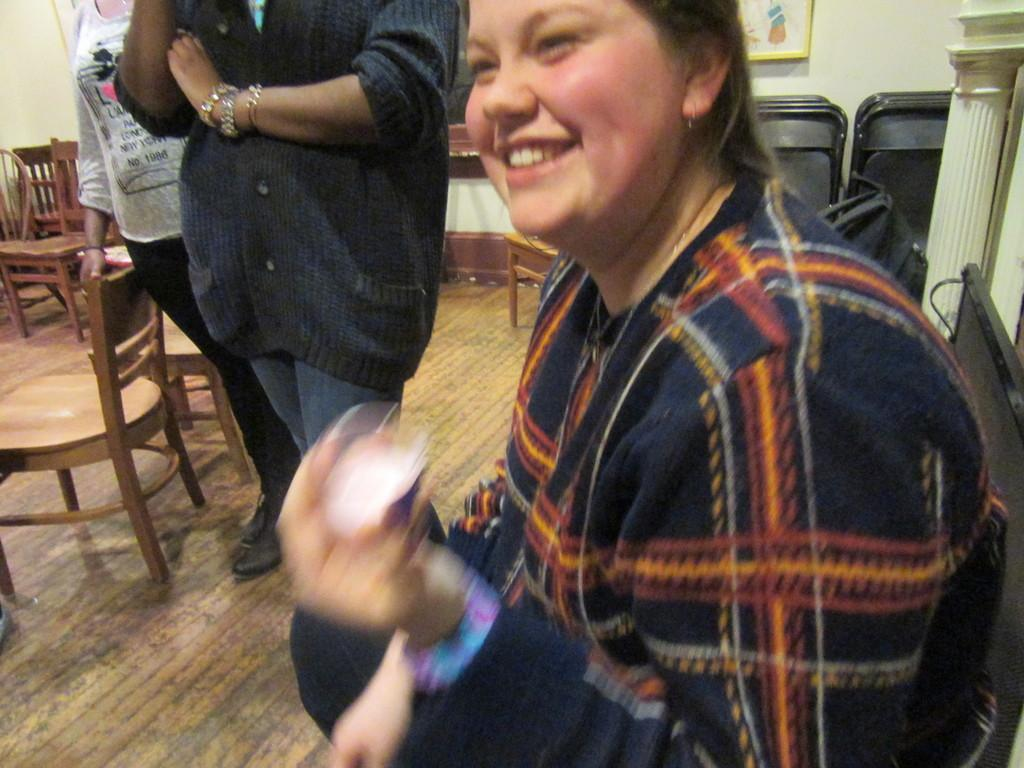How many people are in the image? There are three persons in the image. What is the position of the woman in the image? The woman is seated on a chair. What are the other two persons doing in the image? The other two persons are standing. How many chairs are visible in the image? There are at least two chairs in the image. What can be seen on the wall in the image? There is a wall painting in the image. What type of scientific error can be seen in the image? There is no scientific error present in the image. What is the judge's opinion on the matter in the image? There is no judge present in the image, so it is not possible to determine their opinion on any matter. 